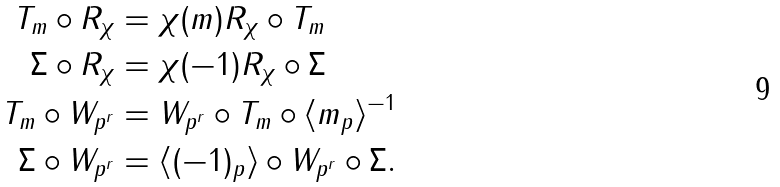Convert formula to latex. <formula><loc_0><loc_0><loc_500><loc_500>T _ { m } \circ R _ { \chi } & = \chi ( m ) R _ { \chi } \circ T _ { m } \\ \Sigma \circ R _ { \chi } & = \chi ( - 1 ) R _ { \chi } \circ \Sigma \\ T _ { m } \circ W _ { p ^ { r } } & = W _ { p ^ { r } } \circ T _ { m } \circ \langle m _ { p } \rangle ^ { - 1 } \\ \Sigma \circ W _ { p ^ { r } } & = \langle ( - 1 ) _ { p } \rangle \circ W _ { p ^ { r } } \circ \Sigma .</formula> 